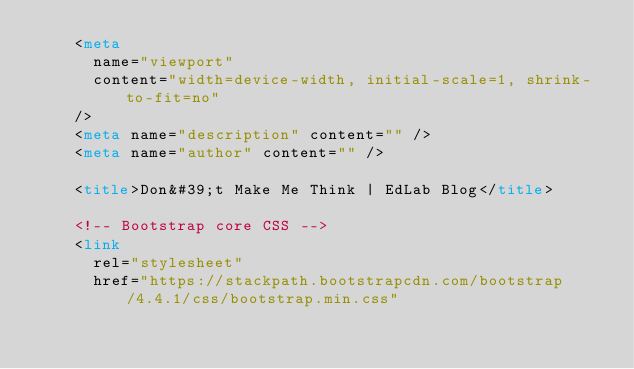Convert code to text. <code><loc_0><loc_0><loc_500><loc_500><_HTML_>    <meta
      name="viewport"
      content="width=device-width, initial-scale=1, shrink-to-fit=no"
    />
    <meta name="description" content="" />
    <meta name="author" content="" />

    <title>Don&#39;t Make Me Think | EdLab Blog</title>

    <!-- Bootstrap core CSS -->
    <link
      rel="stylesheet"
      href="https://stackpath.bootstrapcdn.com/bootstrap/4.4.1/css/bootstrap.min.css"</code> 